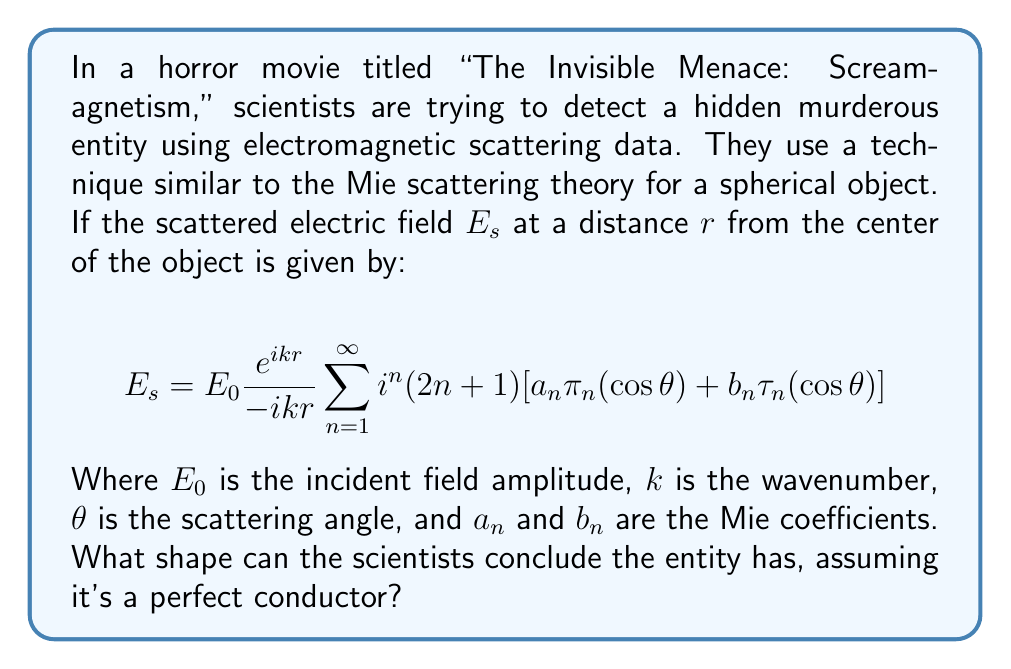Provide a solution to this math problem. To determine the shape of the hidden object, we need to analyze the given equation and its implications:

1) The equation provided is the exact solution for the scattered electric field from a sphere in the Mie scattering regime.

2) Key features of this equation that indicate a spherical shape:
   a) The summation over $n$ represents the multipole expansion, which is characteristic of spherical symmetry.
   b) The angular dependence is given by $\pi_n(\cos\theta)$ and $\tau_n(\cos\theta)$, which are associated Legendre polynomials and their derivatives, respectively. These functions naturally arise in solutions to problems with spherical symmetry.

3) The Mie coefficients $a_n$ and $b_n$ depend on the size parameter $x = ka$, where $a$ is the radius of the sphere, and the relative refractive index. For a perfect conductor, these coefficients have specific forms that ensure the tangential electric field vanishes at the surface.

4) The radial dependence $\frac{e^{ikr}}{-ikr}$ represents an outgoing spherical wave, which is consistent with scattering from a spherical object.

5) The fact that the scattered field can be expressed in this form, with no dependence on the azimuthal angle $\phi$, further confirms the spherical symmetry of the scatterer.

Given that this equation perfectly describes the scattering from a sphere and assumes spherical symmetry in its derivation, the scientists can conclude that the hidden entity must be spherical in shape.
Answer: Spherical 